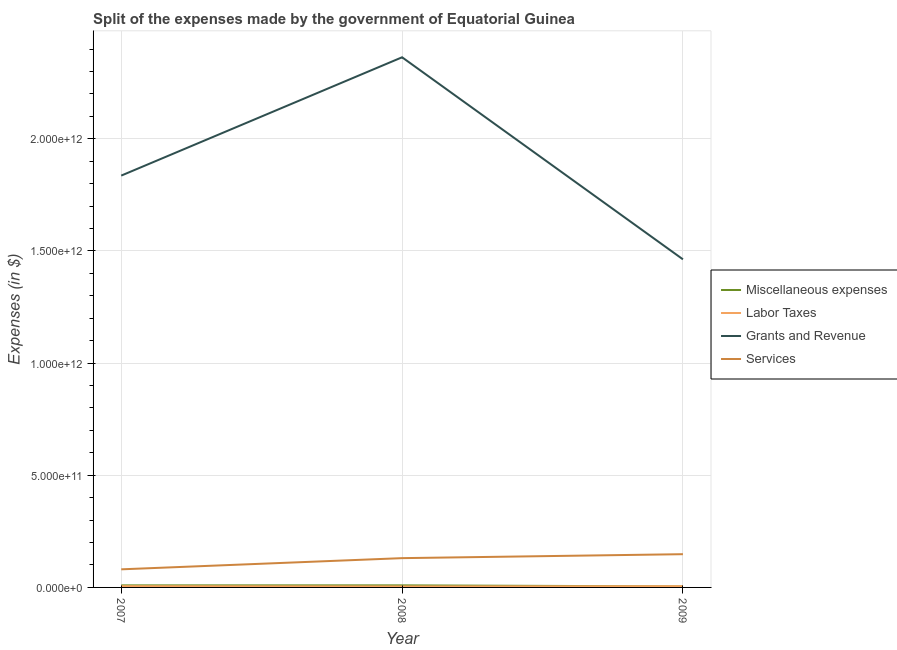How many different coloured lines are there?
Ensure brevity in your answer.  4. Does the line corresponding to amount spent on labor taxes intersect with the line corresponding to amount spent on miscellaneous expenses?
Offer a very short reply. Yes. What is the amount spent on grants and revenue in 2009?
Offer a very short reply. 1.46e+12. Across all years, what is the maximum amount spent on grants and revenue?
Make the answer very short. 2.36e+12. Across all years, what is the minimum amount spent on grants and revenue?
Provide a succinct answer. 1.46e+12. In which year was the amount spent on services minimum?
Offer a very short reply. 2007. What is the total amount spent on miscellaneous expenses in the graph?
Offer a terse response. 2.29e+1. What is the difference between the amount spent on grants and revenue in 2008 and that in 2009?
Make the answer very short. 9.01e+11. What is the difference between the amount spent on labor taxes in 2009 and the amount spent on services in 2008?
Give a very brief answer. -1.25e+11. What is the average amount spent on grants and revenue per year?
Your response must be concise. 1.89e+12. In the year 2007, what is the difference between the amount spent on services and amount spent on miscellaneous expenses?
Ensure brevity in your answer.  7.15e+1. In how many years, is the amount spent on grants and revenue greater than 1200000000000 $?
Ensure brevity in your answer.  3. What is the ratio of the amount spent on services in 2007 to that in 2008?
Your answer should be very brief. 0.62. Is the difference between the amount spent on grants and revenue in 2008 and 2009 greater than the difference between the amount spent on miscellaneous expenses in 2008 and 2009?
Keep it short and to the point. Yes. What is the difference between the highest and the second highest amount spent on grants and revenue?
Your answer should be compact. 5.27e+11. What is the difference between the highest and the lowest amount spent on labor taxes?
Your response must be concise. 1.25e+09. In how many years, is the amount spent on services greater than the average amount spent on services taken over all years?
Make the answer very short. 2. Is it the case that in every year, the sum of the amount spent on miscellaneous expenses and amount spent on labor taxes is greater than the amount spent on grants and revenue?
Your response must be concise. No. Is the amount spent on labor taxes strictly greater than the amount spent on grants and revenue over the years?
Your answer should be compact. No. How many lines are there?
Your answer should be compact. 4. What is the difference between two consecutive major ticks on the Y-axis?
Your response must be concise. 5.00e+11. Does the graph contain grids?
Keep it short and to the point. Yes. How many legend labels are there?
Offer a terse response. 4. How are the legend labels stacked?
Keep it short and to the point. Vertical. What is the title of the graph?
Make the answer very short. Split of the expenses made by the government of Equatorial Guinea. Does "UNAIDS" appear as one of the legend labels in the graph?
Ensure brevity in your answer.  No. What is the label or title of the Y-axis?
Make the answer very short. Expenses (in $). What is the Expenses (in $) in Miscellaneous expenses in 2007?
Your answer should be very brief. 9.16e+09. What is the Expenses (in $) in Labor Taxes in 2007?
Your answer should be compact. 5.69e+09. What is the Expenses (in $) in Grants and Revenue in 2007?
Make the answer very short. 1.84e+12. What is the Expenses (in $) in Services in 2007?
Offer a very short reply. 8.07e+1. What is the Expenses (in $) in Miscellaneous expenses in 2008?
Keep it short and to the point. 9.21e+09. What is the Expenses (in $) in Labor Taxes in 2008?
Offer a terse response. 4.44e+09. What is the Expenses (in $) in Grants and Revenue in 2008?
Your response must be concise. 2.36e+12. What is the Expenses (in $) in Services in 2008?
Offer a terse response. 1.31e+11. What is the Expenses (in $) of Miscellaneous expenses in 2009?
Provide a succinct answer. 4.52e+09. What is the Expenses (in $) in Labor Taxes in 2009?
Ensure brevity in your answer.  5.45e+09. What is the Expenses (in $) of Grants and Revenue in 2009?
Offer a very short reply. 1.46e+12. What is the Expenses (in $) in Services in 2009?
Your answer should be very brief. 1.48e+11. Across all years, what is the maximum Expenses (in $) of Miscellaneous expenses?
Your answer should be very brief. 9.21e+09. Across all years, what is the maximum Expenses (in $) of Labor Taxes?
Offer a terse response. 5.69e+09. Across all years, what is the maximum Expenses (in $) of Grants and Revenue?
Give a very brief answer. 2.36e+12. Across all years, what is the maximum Expenses (in $) of Services?
Offer a very short reply. 1.48e+11. Across all years, what is the minimum Expenses (in $) in Miscellaneous expenses?
Provide a succinct answer. 4.52e+09. Across all years, what is the minimum Expenses (in $) of Labor Taxes?
Keep it short and to the point. 4.44e+09. Across all years, what is the minimum Expenses (in $) of Grants and Revenue?
Offer a terse response. 1.46e+12. Across all years, what is the minimum Expenses (in $) of Services?
Ensure brevity in your answer.  8.07e+1. What is the total Expenses (in $) of Miscellaneous expenses in the graph?
Your answer should be very brief. 2.29e+1. What is the total Expenses (in $) in Labor Taxes in the graph?
Give a very brief answer. 1.56e+1. What is the total Expenses (in $) in Grants and Revenue in the graph?
Make the answer very short. 5.66e+12. What is the total Expenses (in $) in Services in the graph?
Offer a very short reply. 3.59e+11. What is the difference between the Expenses (in $) in Miscellaneous expenses in 2007 and that in 2008?
Make the answer very short. -5.30e+07. What is the difference between the Expenses (in $) in Labor Taxes in 2007 and that in 2008?
Make the answer very short. 1.25e+09. What is the difference between the Expenses (in $) in Grants and Revenue in 2007 and that in 2008?
Offer a terse response. -5.27e+11. What is the difference between the Expenses (in $) in Services in 2007 and that in 2008?
Your response must be concise. -4.99e+1. What is the difference between the Expenses (in $) of Miscellaneous expenses in 2007 and that in 2009?
Your response must be concise. 4.63e+09. What is the difference between the Expenses (in $) of Labor Taxes in 2007 and that in 2009?
Provide a succinct answer. 2.42e+08. What is the difference between the Expenses (in $) in Grants and Revenue in 2007 and that in 2009?
Make the answer very short. 3.73e+11. What is the difference between the Expenses (in $) of Services in 2007 and that in 2009?
Give a very brief answer. -6.75e+1. What is the difference between the Expenses (in $) in Miscellaneous expenses in 2008 and that in 2009?
Your response must be concise. 4.69e+09. What is the difference between the Expenses (in $) in Labor Taxes in 2008 and that in 2009?
Provide a succinct answer. -1.01e+09. What is the difference between the Expenses (in $) of Grants and Revenue in 2008 and that in 2009?
Ensure brevity in your answer.  9.01e+11. What is the difference between the Expenses (in $) of Services in 2008 and that in 2009?
Offer a very short reply. -1.76e+1. What is the difference between the Expenses (in $) of Miscellaneous expenses in 2007 and the Expenses (in $) of Labor Taxes in 2008?
Your answer should be very brief. 4.72e+09. What is the difference between the Expenses (in $) in Miscellaneous expenses in 2007 and the Expenses (in $) in Grants and Revenue in 2008?
Provide a short and direct response. -2.35e+12. What is the difference between the Expenses (in $) in Miscellaneous expenses in 2007 and the Expenses (in $) in Services in 2008?
Offer a very short reply. -1.21e+11. What is the difference between the Expenses (in $) of Labor Taxes in 2007 and the Expenses (in $) of Grants and Revenue in 2008?
Provide a succinct answer. -2.36e+12. What is the difference between the Expenses (in $) of Labor Taxes in 2007 and the Expenses (in $) of Services in 2008?
Ensure brevity in your answer.  -1.25e+11. What is the difference between the Expenses (in $) of Grants and Revenue in 2007 and the Expenses (in $) of Services in 2008?
Offer a very short reply. 1.71e+12. What is the difference between the Expenses (in $) of Miscellaneous expenses in 2007 and the Expenses (in $) of Labor Taxes in 2009?
Your answer should be very brief. 3.71e+09. What is the difference between the Expenses (in $) of Miscellaneous expenses in 2007 and the Expenses (in $) of Grants and Revenue in 2009?
Your response must be concise. -1.45e+12. What is the difference between the Expenses (in $) in Miscellaneous expenses in 2007 and the Expenses (in $) in Services in 2009?
Provide a short and direct response. -1.39e+11. What is the difference between the Expenses (in $) of Labor Taxes in 2007 and the Expenses (in $) of Grants and Revenue in 2009?
Offer a very short reply. -1.46e+12. What is the difference between the Expenses (in $) in Labor Taxes in 2007 and the Expenses (in $) in Services in 2009?
Ensure brevity in your answer.  -1.43e+11. What is the difference between the Expenses (in $) in Grants and Revenue in 2007 and the Expenses (in $) in Services in 2009?
Provide a short and direct response. 1.69e+12. What is the difference between the Expenses (in $) in Miscellaneous expenses in 2008 and the Expenses (in $) in Labor Taxes in 2009?
Keep it short and to the point. 3.76e+09. What is the difference between the Expenses (in $) of Miscellaneous expenses in 2008 and the Expenses (in $) of Grants and Revenue in 2009?
Keep it short and to the point. -1.45e+12. What is the difference between the Expenses (in $) of Miscellaneous expenses in 2008 and the Expenses (in $) of Services in 2009?
Give a very brief answer. -1.39e+11. What is the difference between the Expenses (in $) of Labor Taxes in 2008 and the Expenses (in $) of Grants and Revenue in 2009?
Your response must be concise. -1.46e+12. What is the difference between the Expenses (in $) in Labor Taxes in 2008 and the Expenses (in $) in Services in 2009?
Offer a terse response. -1.44e+11. What is the difference between the Expenses (in $) in Grants and Revenue in 2008 and the Expenses (in $) in Services in 2009?
Make the answer very short. 2.21e+12. What is the average Expenses (in $) of Miscellaneous expenses per year?
Ensure brevity in your answer.  7.63e+09. What is the average Expenses (in $) in Labor Taxes per year?
Make the answer very short. 5.19e+09. What is the average Expenses (in $) of Grants and Revenue per year?
Give a very brief answer. 1.89e+12. What is the average Expenses (in $) in Services per year?
Ensure brevity in your answer.  1.20e+11. In the year 2007, what is the difference between the Expenses (in $) of Miscellaneous expenses and Expenses (in $) of Labor Taxes?
Your answer should be very brief. 3.47e+09. In the year 2007, what is the difference between the Expenses (in $) in Miscellaneous expenses and Expenses (in $) in Grants and Revenue?
Keep it short and to the point. -1.83e+12. In the year 2007, what is the difference between the Expenses (in $) of Miscellaneous expenses and Expenses (in $) of Services?
Offer a very short reply. -7.15e+1. In the year 2007, what is the difference between the Expenses (in $) in Labor Taxes and Expenses (in $) in Grants and Revenue?
Give a very brief answer. -1.83e+12. In the year 2007, what is the difference between the Expenses (in $) in Labor Taxes and Expenses (in $) in Services?
Provide a succinct answer. -7.50e+1. In the year 2007, what is the difference between the Expenses (in $) of Grants and Revenue and Expenses (in $) of Services?
Your response must be concise. 1.76e+12. In the year 2008, what is the difference between the Expenses (in $) in Miscellaneous expenses and Expenses (in $) in Labor Taxes?
Offer a terse response. 4.77e+09. In the year 2008, what is the difference between the Expenses (in $) in Miscellaneous expenses and Expenses (in $) in Grants and Revenue?
Your answer should be very brief. -2.35e+12. In the year 2008, what is the difference between the Expenses (in $) of Miscellaneous expenses and Expenses (in $) of Services?
Provide a succinct answer. -1.21e+11. In the year 2008, what is the difference between the Expenses (in $) of Labor Taxes and Expenses (in $) of Grants and Revenue?
Provide a short and direct response. -2.36e+12. In the year 2008, what is the difference between the Expenses (in $) of Labor Taxes and Expenses (in $) of Services?
Provide a succinct answer. -1.26e+11. In the year 2008, what is the difference between the Expenses (in $) of Grants and Revenue and Expenses (in $) of Services?
Provide a succinct answer. 2.23e+12. In the year 2009, what is the difference between the Expenses (in $) in Miscellaneous expenses and Expenses (in $) in Labor Taxes?
Your answer should be very brief. -9.26e+08. In the year 2009, what is the difference between the Expenses (in $) in Miscellaneous expenses and Expenses (in $) in Grants and Revenue?
Offer a terse response. -1.46e+12. In the year 2009, what is the difference between the Expenses (in $) in Miscellaneous expenses and Expenses (in $) in Services?
Your answer should be very brief. -1.44e+11. In the year 2009, what is the difference between the Expenses (in $) in Labor Taxes and Expenses (in $) in Grants and Revenue?
Your response must be concise. -1.46e+12. In the year 2009, what is the difference between the Expenses (in $) of Labor Taxes and Expenses (in $) of Services?
Provide a short and direct response. -1.43e+11. In the year 2009, what is the difference between the Expenses (in $) of Grants and Revenue and Expenses (in $) of Services?
Provide a succinct answer. 1.31e+12. What is the ratio of the Expenses (in $) in Labor Taxes in 2007 to that in 2008?
Keep it short and to the point. 1.28. What is the ratio of the Expenses (in $) of Grants and Revenue in 2007 to that in 2008?
Your response must be concise. 0.78. What is the ratio of the Expenses (in $) in Services in 2007 to that in 2008?
Keep it short and to the point. 0.62. What is the ratio of the Expenses (in $) in Miscellaneous expenses in 2007 to that in 2009?
Offer a very short reply. 2.02. What is the ratio of the Expenses (in $) of Labor Taxes in 2007 to that in 2009?
Your response must be concise. 1.04. What is the ratio of the Expenses (in $) of Grants and Revenue in 2007 to that in 2009?
Ensure brevity in your answer.  1.26. What is the ratio of the Expenses (in $) of Services in 2007 to that in 2009?
Your response must be concise. 0.54. What is the ratio of the Expenses (in $) in Miscellaneous expenses in 2008 to that in 2009?
Ensure brevity in your answer.  2.04. What is the ratio of the Expenses (in $) in Labor Taxes in 2008 to that in 2009?
Your answer should be compact. 0.81. What is the ratio of the Expenses (in $) of Grants and Revenue in 2008 to that in 2009?
Offer a terse response. 1.62. What is the ratio of the Expenses (in $) in Services in 2008 to that in 2009?
Make the answer very short. 0.88. What is the difference between the highest and the second highest Expenses (in $) in Miscellaneous expenses?
Your response must be concise. 5.30e+07. What is the difference between the highest and the second highest Expenses (in $) in Labor Taxes?
Offer a very short reply. 2.42e+08. What is the difference between the highest and the second highest Expenses (in $) of Grants and Revenue?
Ensure brevity in your answer.  5.27e+11. What is the difference between the highest and the second highest Expenses (in $) of Services?
Your answer should be very brief. 1.76e+1. What is the difference between the highest and the lowest Expenses (in $) in Miscellaneous expenses?
Your response must be concise. 4.69e+09. What is the difference between the highest and the lowest Expenses (in $) in Labor Taxes?
Make the answer very short. 1.25e+09. What is the difference between the highest and the lowest Expenses (in $) in Grants and Revenue?
Your response must be concise. 9.01e+11. What is the difference between the highest and the lowest Expenses (in $) in Services?
Provide a succinct answer. 6.75e+1. 